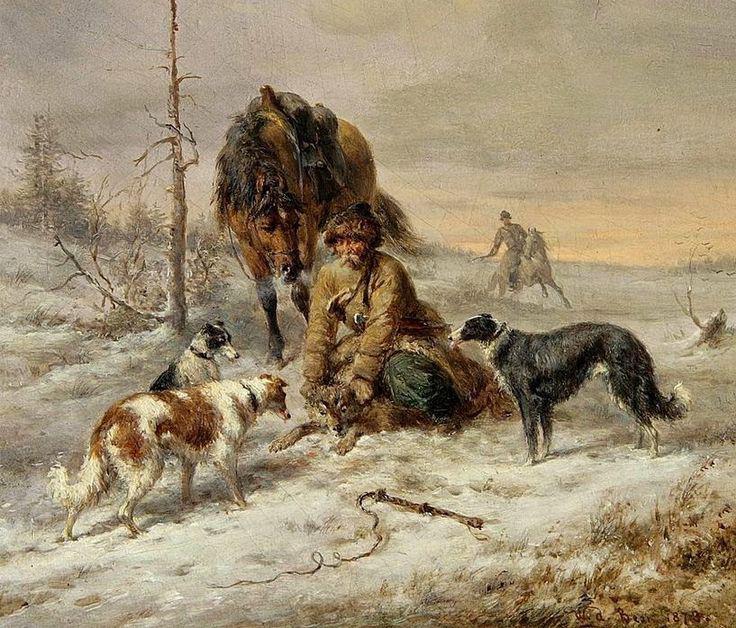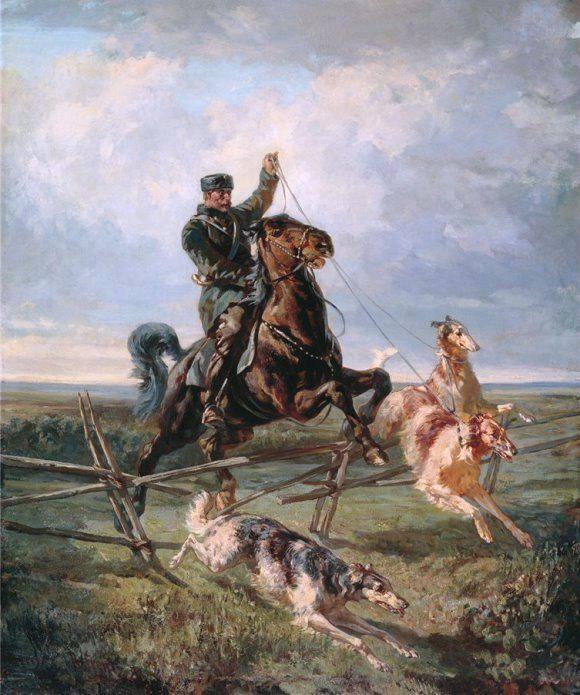The first image is the image on the left, the second image is the image on the right. Given the left and right images, does the statement "An image features a horse rearing up with raised front legs, behind multiple dogs." hold true? Answer yes or no. Yes. 